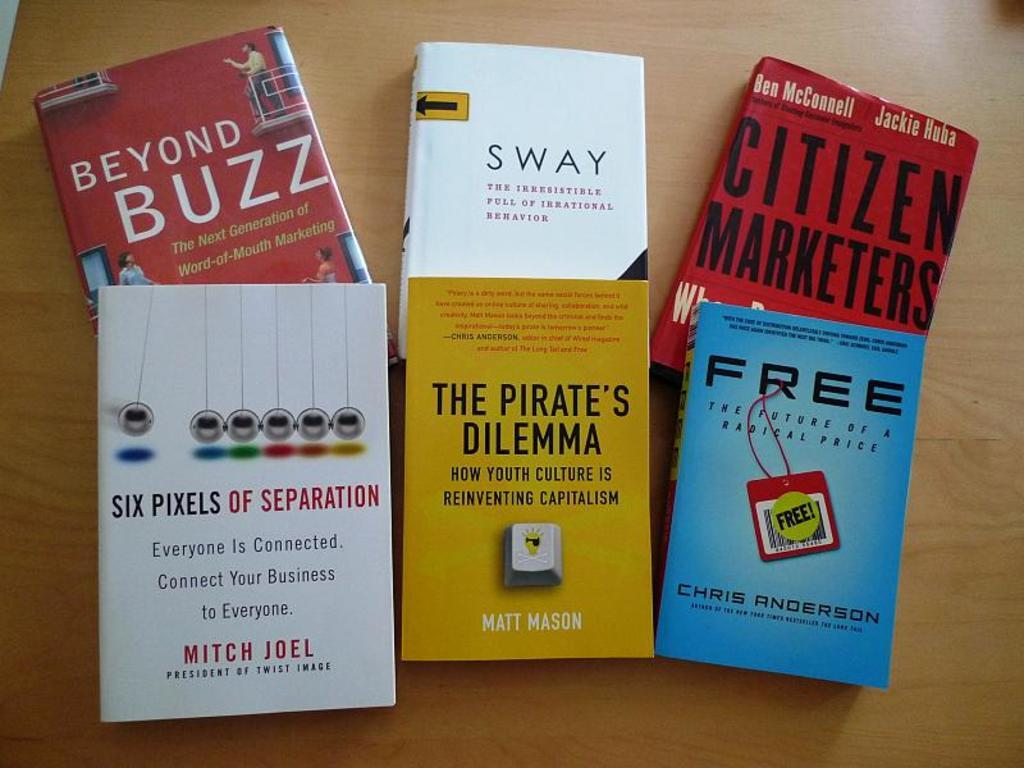<image>
Present a compact description of the photo's key features. 6 books on the table called free, the pirates dilemman 